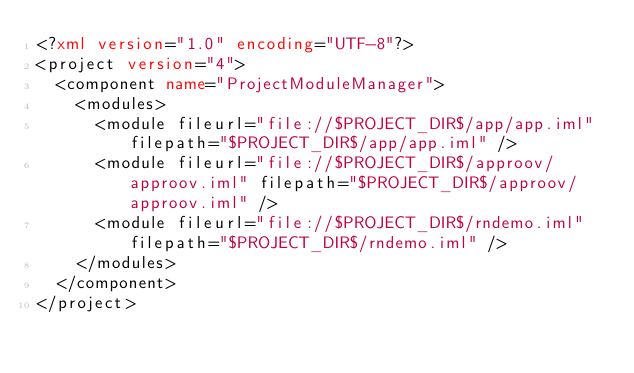<code> <loc_0><loc_0><loc_500><loc_500><_XML_><?xml version="1.0" encoding="UTF-8"?>
<project version="4">
  <component name="ProjectModuleManager">
    <modules>
      <module fileurl="file://$PROJECT_DIR$/app/app.iml" filepath="$PROJECT_DIR$/app/app.iml" />
      <module fileurl="file://$PROJECT_DIR$/approov/approov.iml" filepath="$PROJECT_DIR$/approov/approov.iml" />
      <module fileurl="file://$PROJECT_DIR$/rndemo.iml" filepath="$PROJECT_DIR$/rndemo.iml" />
    </modules>
  </component>
</project></code> 